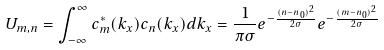<formula> <loc_0><loc_0><loc_500><loc_500>U _ { m , n } = \int _ { - \infty } ^ { \infty } c ^ { * } _ { m } ( k _ { x } ) c _ { n } ( k _ { x } ) d k _ { x } = \frac { 1 } { \pi \sigma } e ^ { - \frac { ( n - n _ { 0 } ) ^ { 2 } } { 2 \sigma } } e ^ { - \frac { ( m - n _ { 0 } ) ^ { 2 } } { 2 \sigma } }</formula> 